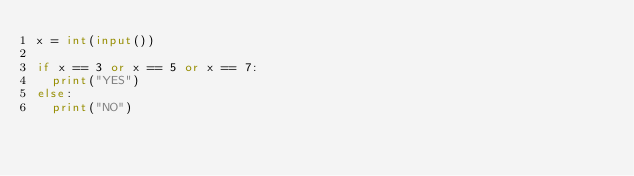<code> <loc_0><loc_0><loc_500><loc_500><_Python_>x = int(input())

if x == 3 or x == 5 or x == 7:
  print("YES")
else:
  print("NO")</code> 